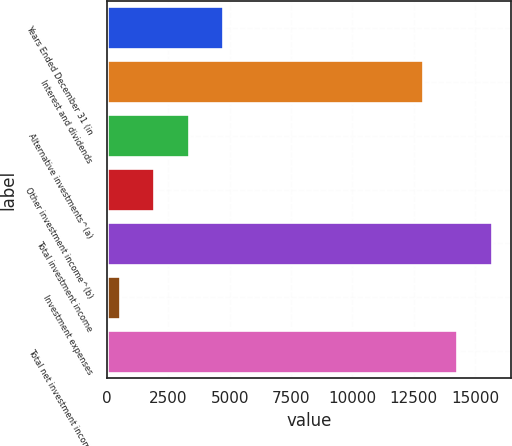Convert chart. <chart><loc_0><loc_0><loc_500><loc_500><bar_chart><fcel>Years Ended December 31 (in<fcel>Interest and dividends<fcel>Alternative investments^(a)<fcel>Other investment income^(b)<fcel>Total investment income<fcel>Investment expenses<fcel>Total net investment income<nl><fcel>4743.9<fcel>12856<fcel>3338.6<fcel>1933.3<fcel>15666.6<fcel>528<fcel>14261.3<nl></chart> 